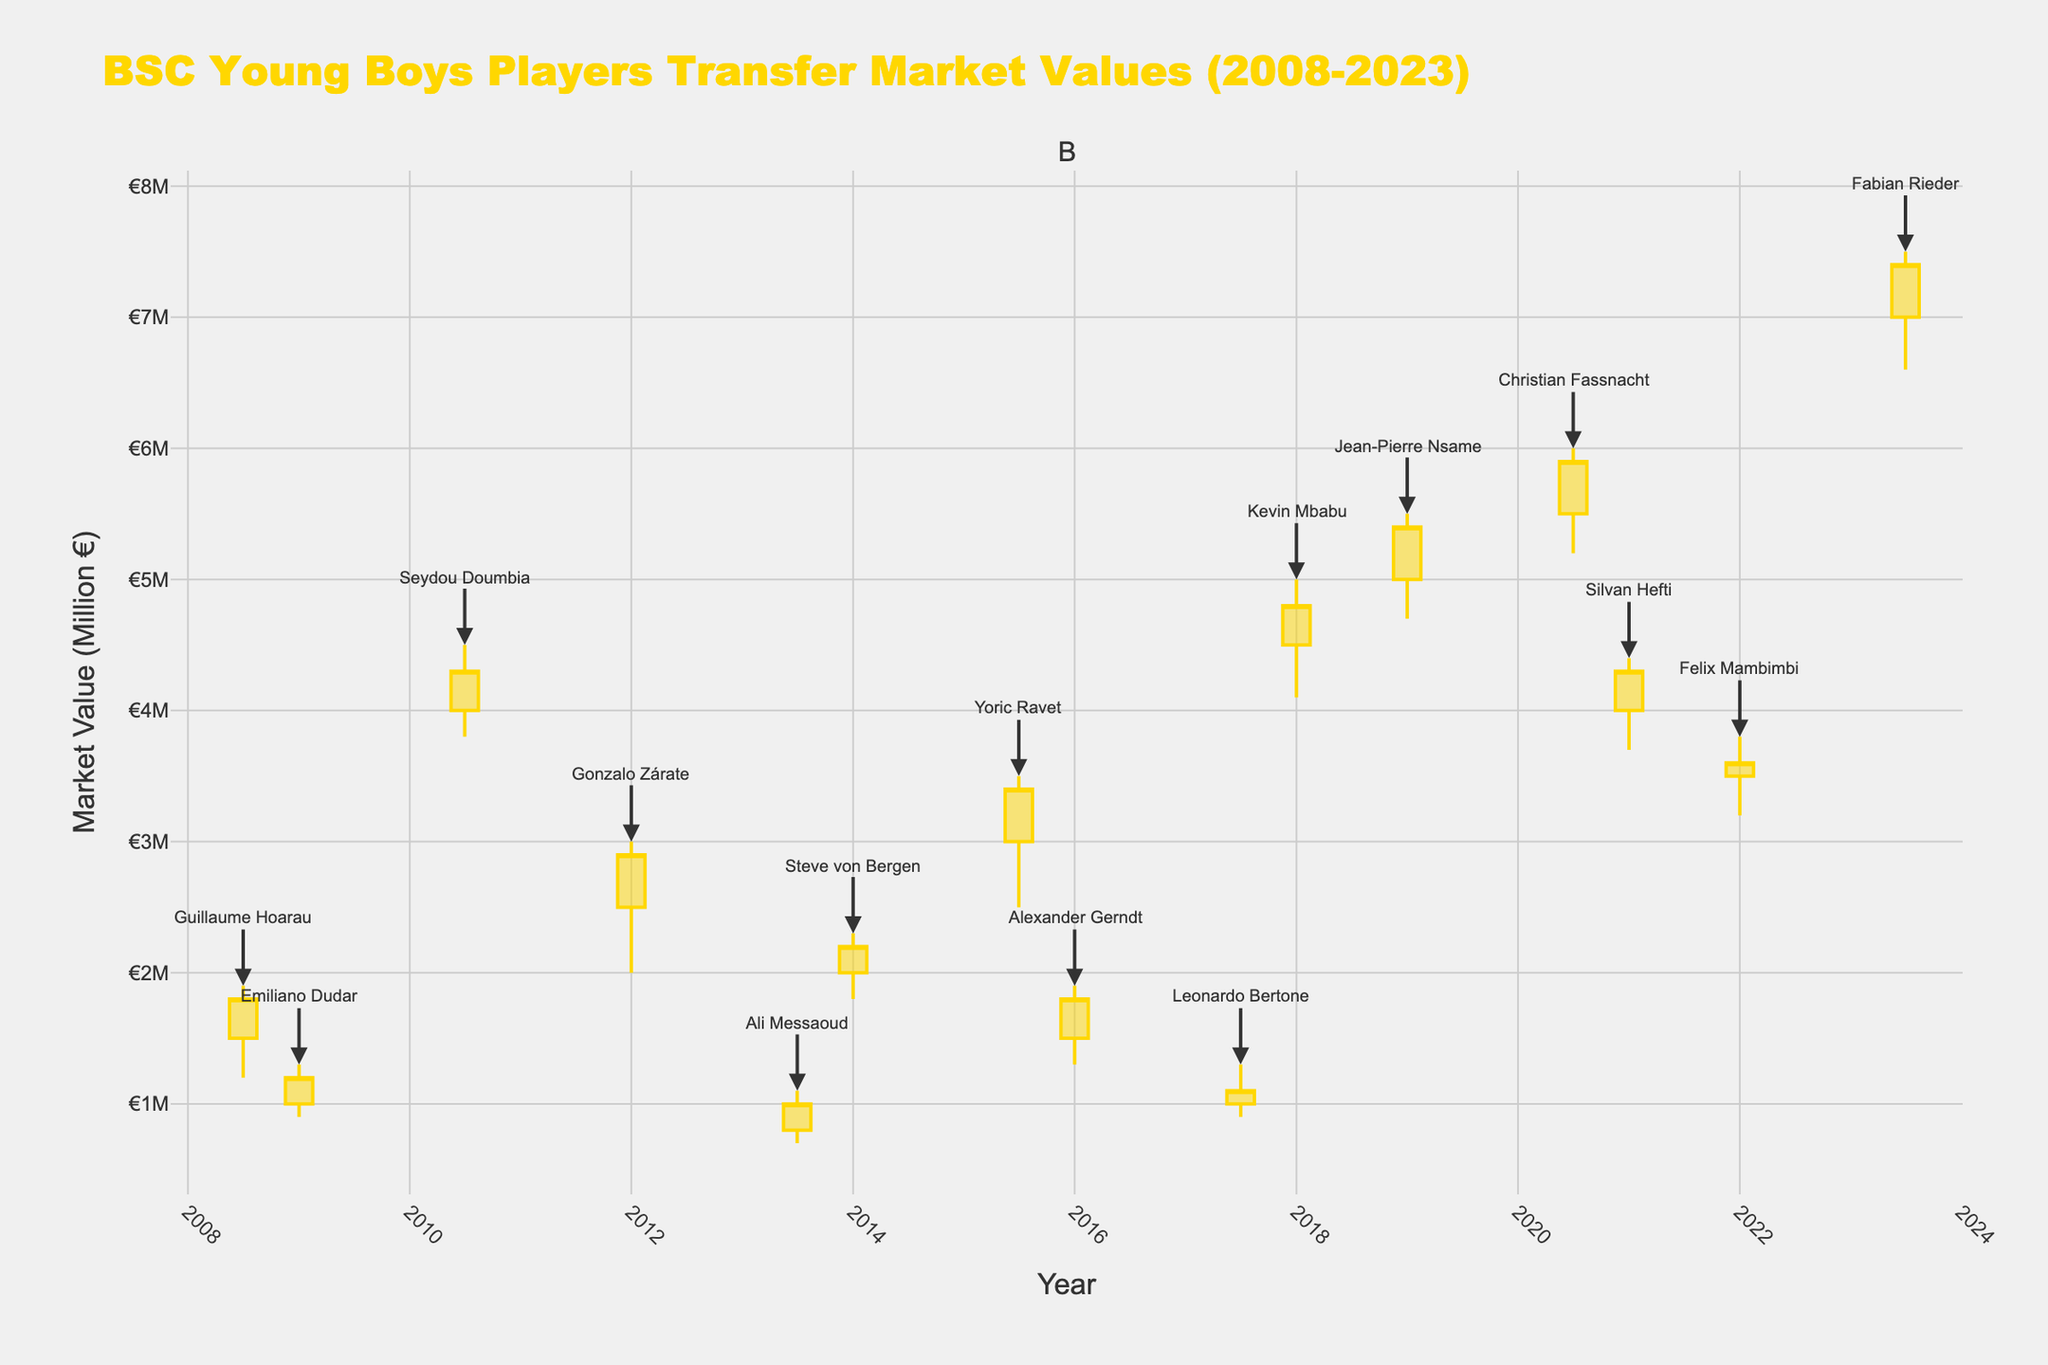What is the title of the plot? The title of the plot is displayed at the top of the figure.
Answer: BSC Young Boys Players Transfer Market Values (2008-2023) Which two players had the highest market value in the plot? The highest market values are represented by the upper shadows of the candlesticks. Identify the two players with the highest upper shadows.
Answer: Fabian Rieder and Christian Fassnacht During which year did Jean-Pierre Nsame have a close value of 5.4 million euros? Look for the candlestick with a close value of 5.4 million euros and identify the corresponding year and player.
Answer: 2019 What is the range of values for Kevin Mbabu's market value in January 2018? The range is calculated by subtracting the low value from the high value in January 2018 for Kevin Mbabu's candlestick. High: 5.0, Low: 4.1. Range = 5.0 - 4.1
Answer: 0.9 million euros During which year did Silvan Hefti have a market value increase as portrayed by the candlestick? A market value increase is represented by a candlestick where the close value is higher than the open value. Identify the year of Silvan Hefti's increasing candlestick.
Answer: 2021 Which player had the lowest market value in January 2016? Identify the player with a candlestick having the lowest values in January 2016 by examining the lowest shadows of candlesticks.
Answer: Alexander Gerndt Among the three players with the highest closing market values, who are they? Look at the heights of candlesticks' closing values and identify the three players with the highest closing values.
Answer: Fabian Rieder, Christian Fassnacht, Jean-Pierre Nsame Calculate the median high value of players' market values from the plot. List out all the high values from each candlestick and find the median (middle value in an ordered list). High values: 1.9, 1.3, 4.5, 3.0, 1.1, 2.3, 3.5, 1.9, 1.3, 5.0, 5.5, 6.0, 4.4, 3.8, 7.5. Ordered: 1.1, 1.3, 1.3, 1.9, 1.9, 2.3, 3.0, 3.5, 3.8, 4.4, 4.5, 5.0, 5.5, 6.0, 7.5. Median = 3.5
Answer: 3.5 million euros Which player name annotation is closest to the bottom of the plot? The player name annotation closest to the bottom will be associated with the lowest candlestick’s low value. Identify the corresponding player.
Answer: Ali Messaoud 